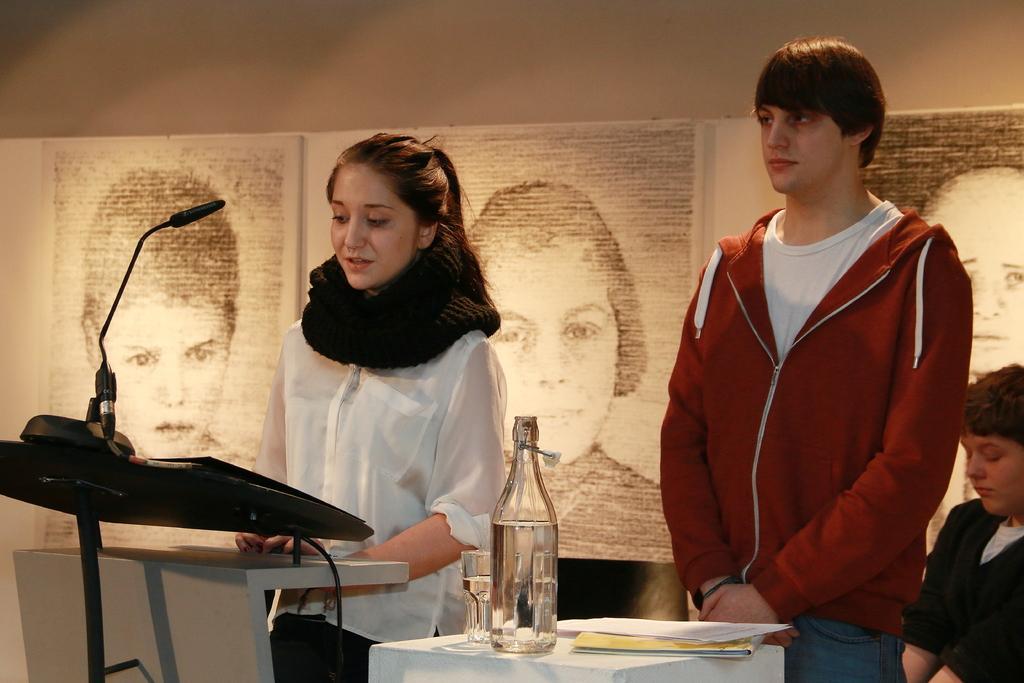In one or two sentences, can you explain what this image depicts? This picture shows a girl and a boy standing. A girl is standing in front of a podium. There is a microphone in front of her. We can observe a bottle and a glass along with some papers were placed on the table. In the background there are some sketches attached to the wall. 